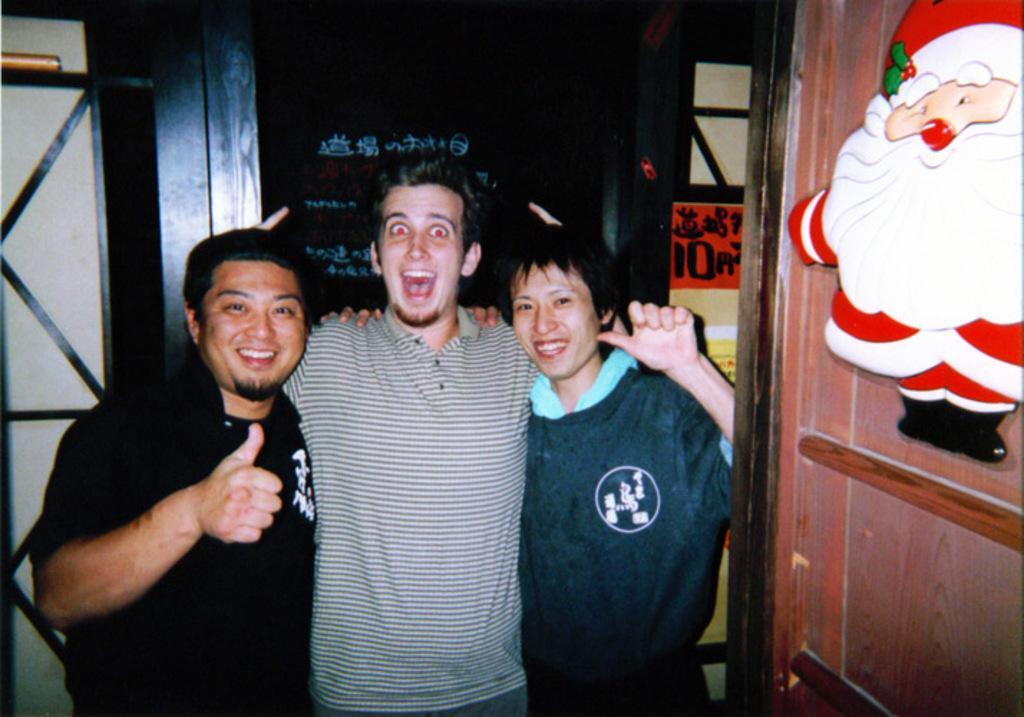How would you summarize this image in a sentence or two? In this picture we can see two men and a woman standing and smiling and in the background we can see posters. 